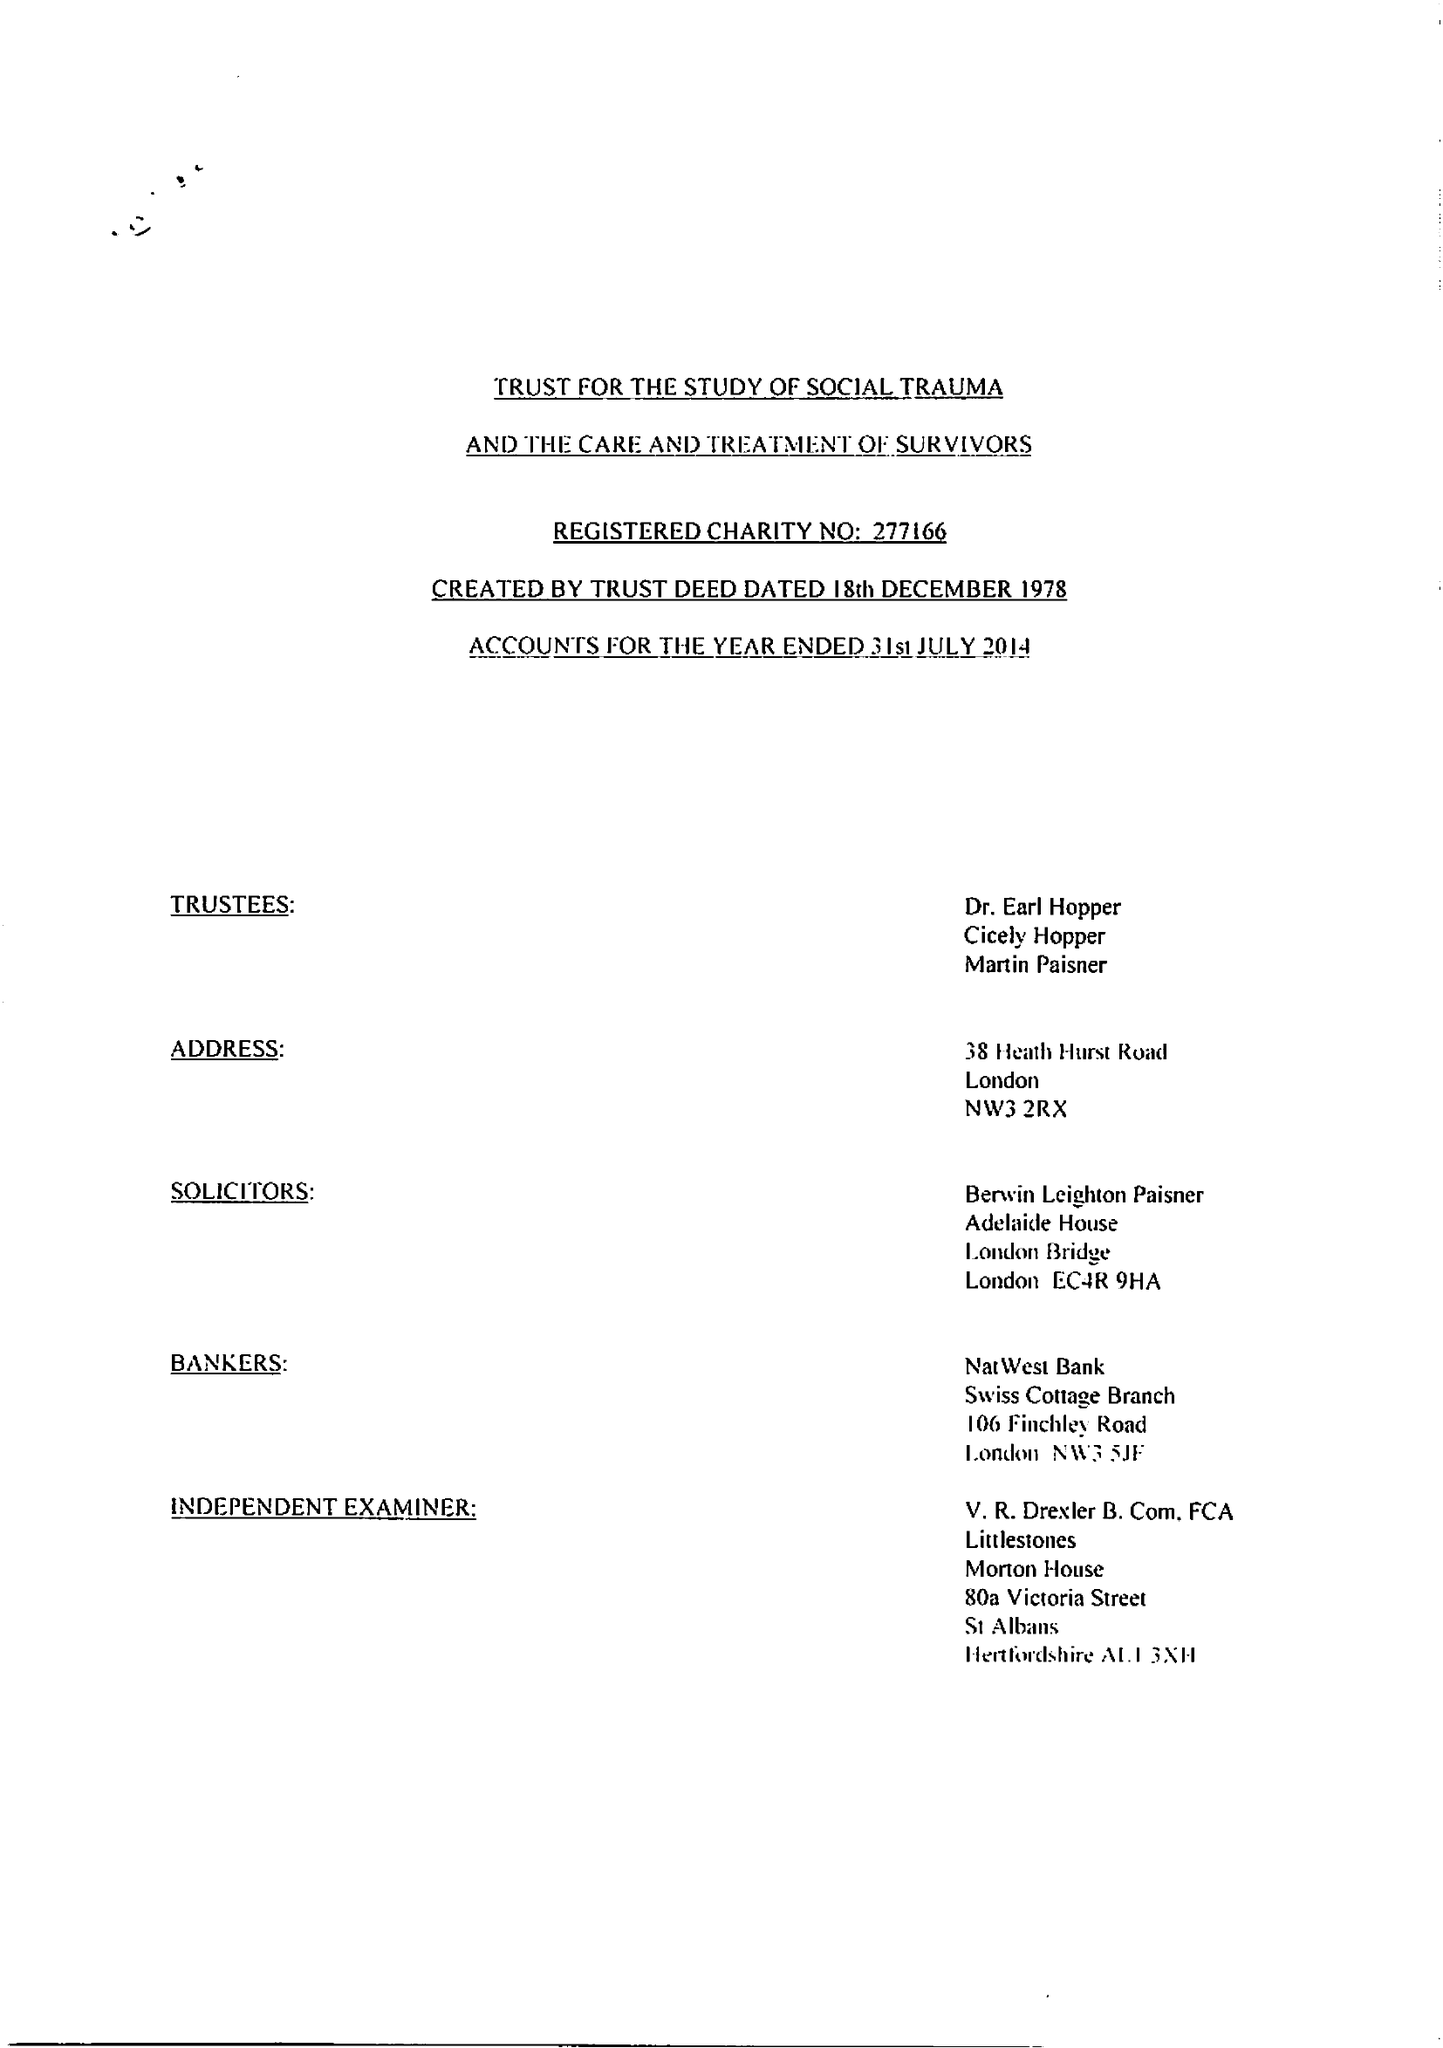What is the value for the report_date?
Answer the question using a single word or phrase. 2014-07-31 